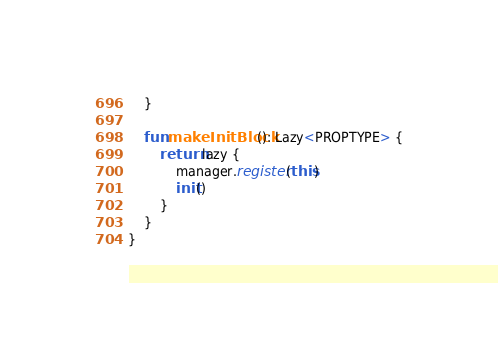Convert code to text. <code><loc_0><loc_0><loc_500><loc_500><_Kotlin_>    }

    fun makeInitBlock(): Lazy<PROPTYPE> {
        return lazy {
            manager.register(this)
            init()
        }
    }
}</code> 